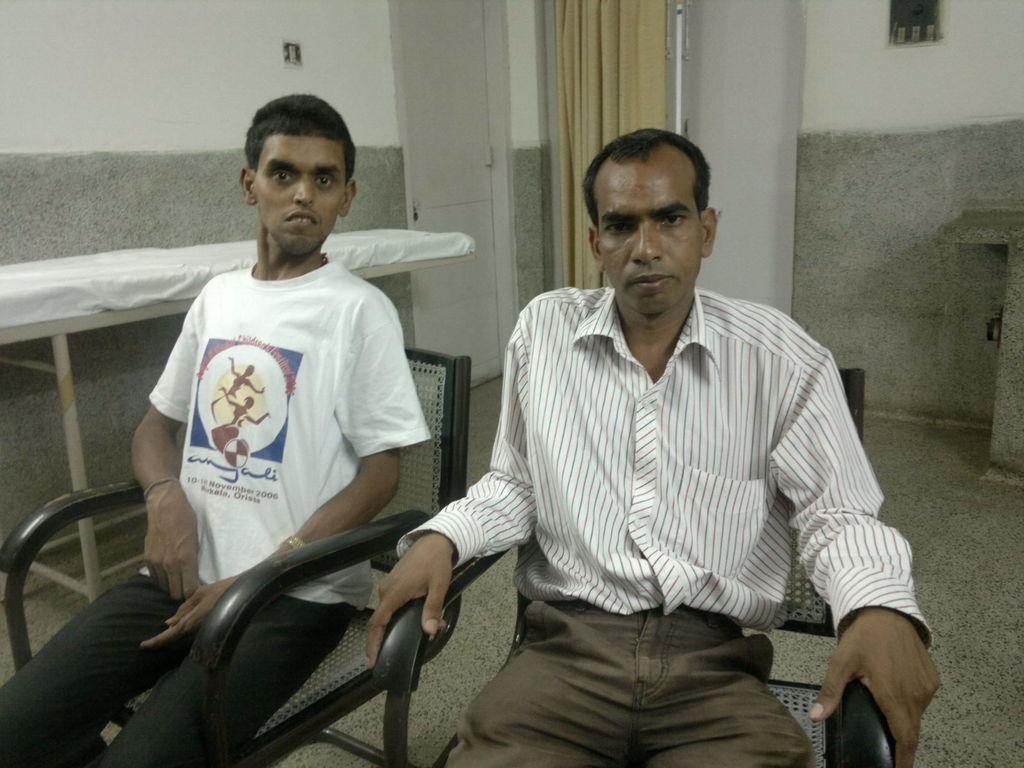Could you give a brief overview of what you see in this image? In this image we can see two men are sitting on the chair. One man is wearing white color t-shirt with black pant and the other one is wearing shirt with brown pant. Behind the bed is present and curtain is there to the white color door. 